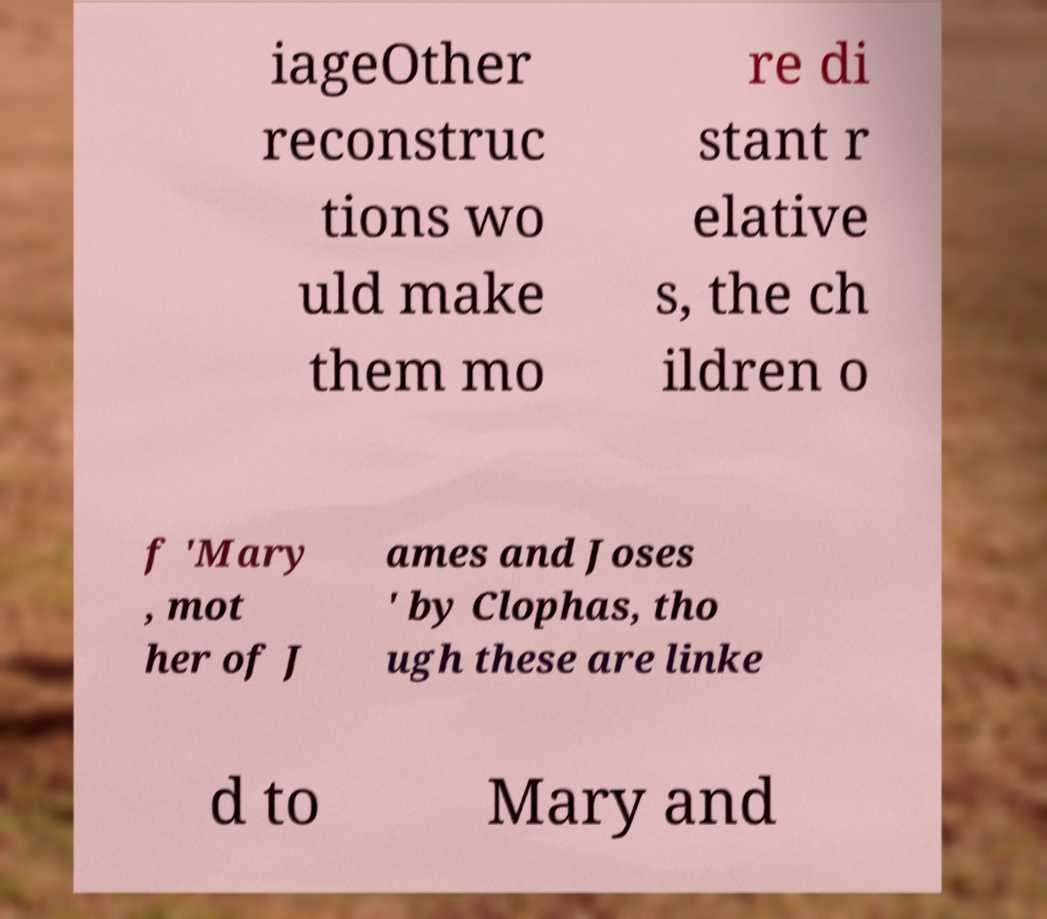Could you extract and type out the text from this image? iageOther reconstruc tions wo uld make them mo re di stant r elative s, the ch ildren o f 'Mary , mot her of J ames and Joses ' by Clophas, tho ugh these are linke d to Mary and 